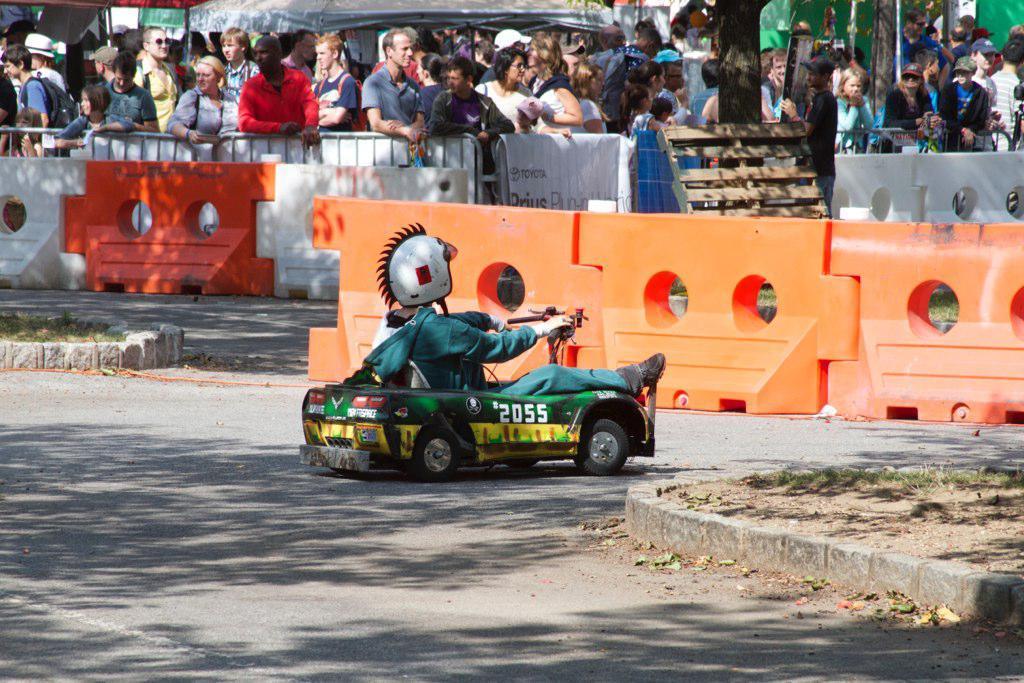Please provide a concise description of this image. In this picture there is a person riding vehicle on the road. At the back there are group of people standing behind the railing and there are tents and there is a tree. In the foreground there are objects on the road. At the bottom there is a road and there is grass. 